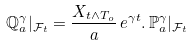<formula> <loc_0><loc_0><loc_500><loc_500>\mathbb { Q } _ { a } ^ { \gamma } | _ { \mathcal { F } _ { t } } = \frac { X _ { t \wedge T _ { o } } } { a } \, e ^ { \gamma t } . \, \mathbb { P } _ { a } ^ { \gamma } | _ { \mathcal { F } _ { t } }</formula> 